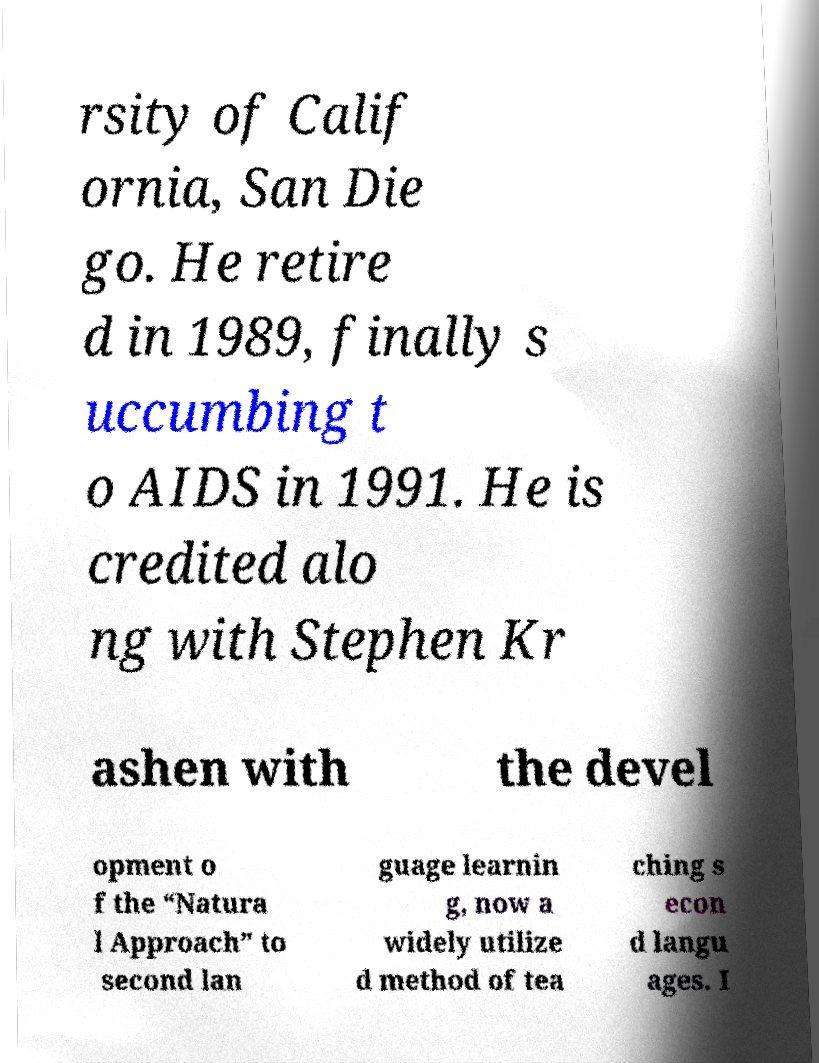Can you accurately transcribe the text from the provided image for me? rsity of Calif ornia, San Die go. He retire d in 1989, finally s uccumbing t o AIDS in 1991. He is credited alo ng with Stephen Kr ashen with the devel opment o f the “Natura l Approach” to second lan guage learnin g, now a widely utilize d method of tea ching s econ d langu ages. I 